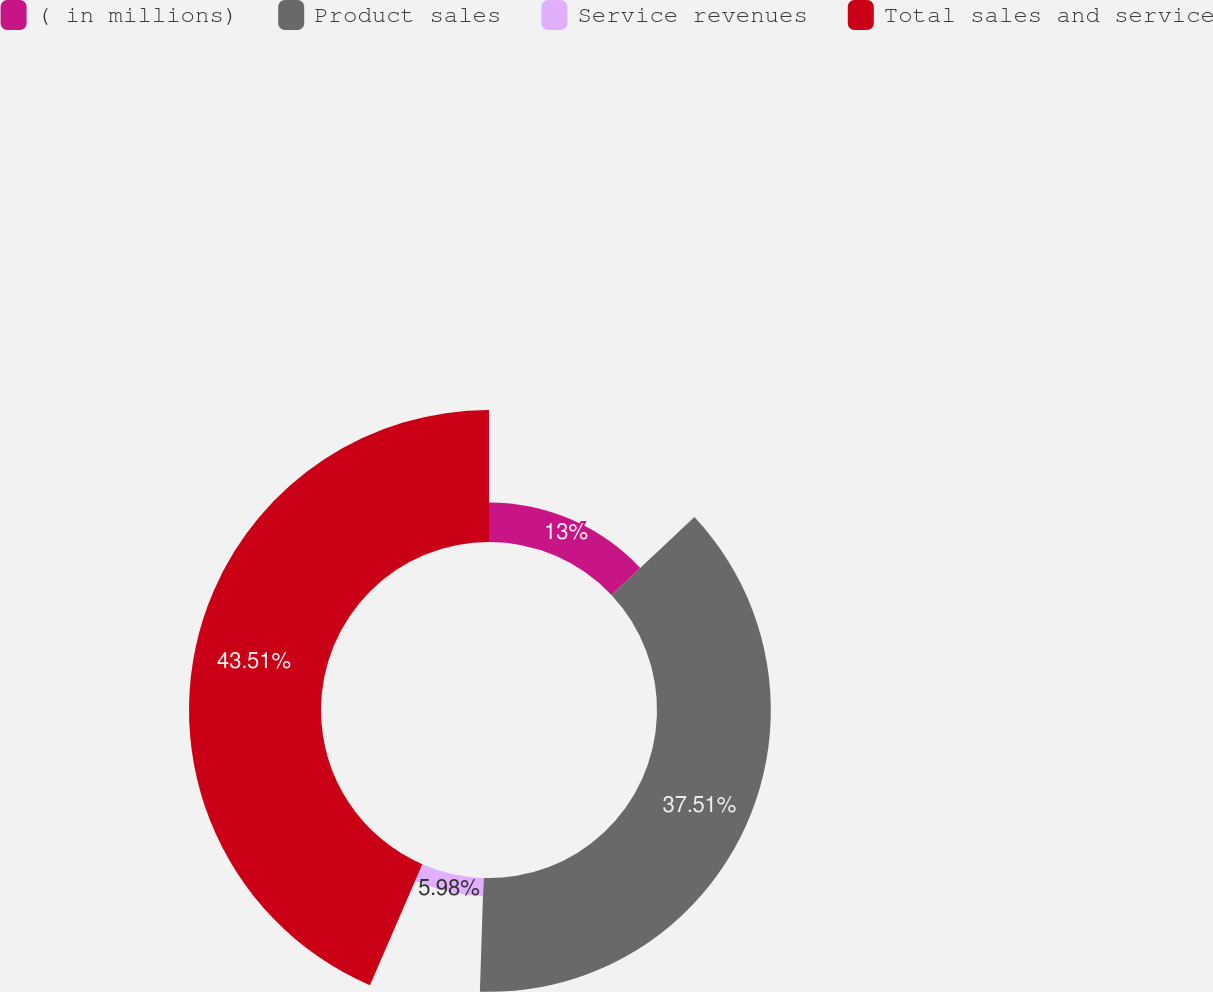Convert chart. <chart><loc_0><loc_0><loc_500><loc_500><pie_chart><fcel>( in millions)<fcel>Product sales<fcel>Service revenues<fcel>Total sales and service<nl><fcel>13.0%<fcel>37.51%<fcel>5.98%<fcel>43.5%<nl></chart> 